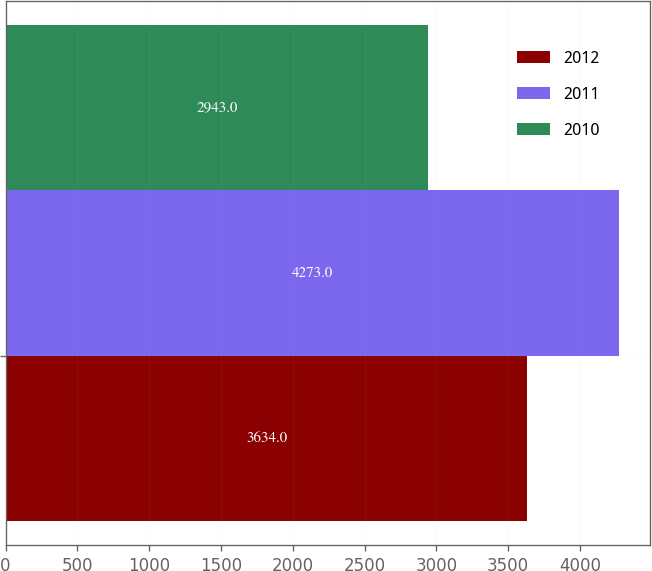Convert chart. <chart><loc_0><loc_0><loc_500><loc_500><stacked_bar_chart><ecel><fcel>Unnamed: 1<nl><fcel>2012<fcel>3634<nl><fcel>2011<fcel>4273<nl><fcel>2010<fcel>2943<nl></chart> 